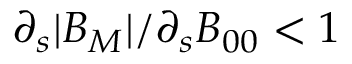Convert formula to latex. <formula><loc_0><loc_0><loc_500><loc_500>\partial _ { s } | B _ { M } | / \partial _ { s } B _ { 0 0 } < 1</formula> 